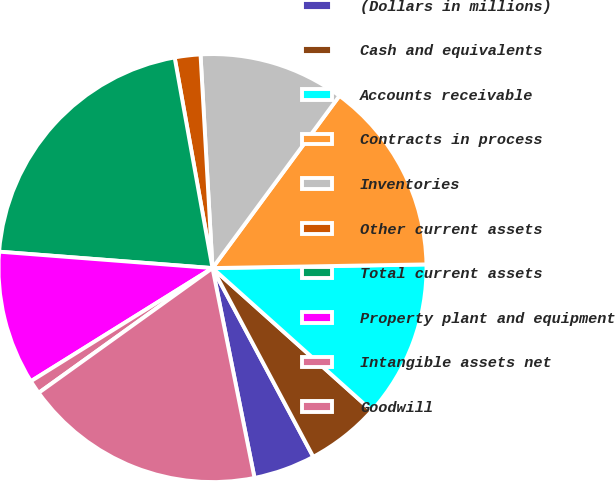Convert chart. <chart><loc_0><loc_0><loc_500><loc_500><pie_chart><fcel>(Dollars in millions)<fcel>Cash and equivalents<fcel>Accounts receivable<fcel>Contracts in process<fcel>Inventories<fcel>Other current assets<fcel>Total current assets<fcel>Property plant and equipment<fcel>Intangible assets net<fcel>Goodwill<nl><fcel>4.66%<fcel>5.57%<fcel>11.9%<fcel>14.62%<fcel>11.0%<fcel>1.94%<fcel>20.95%<fcel>10.09%<fcel>1.04%<fcel>18.24%<nl></chart> 